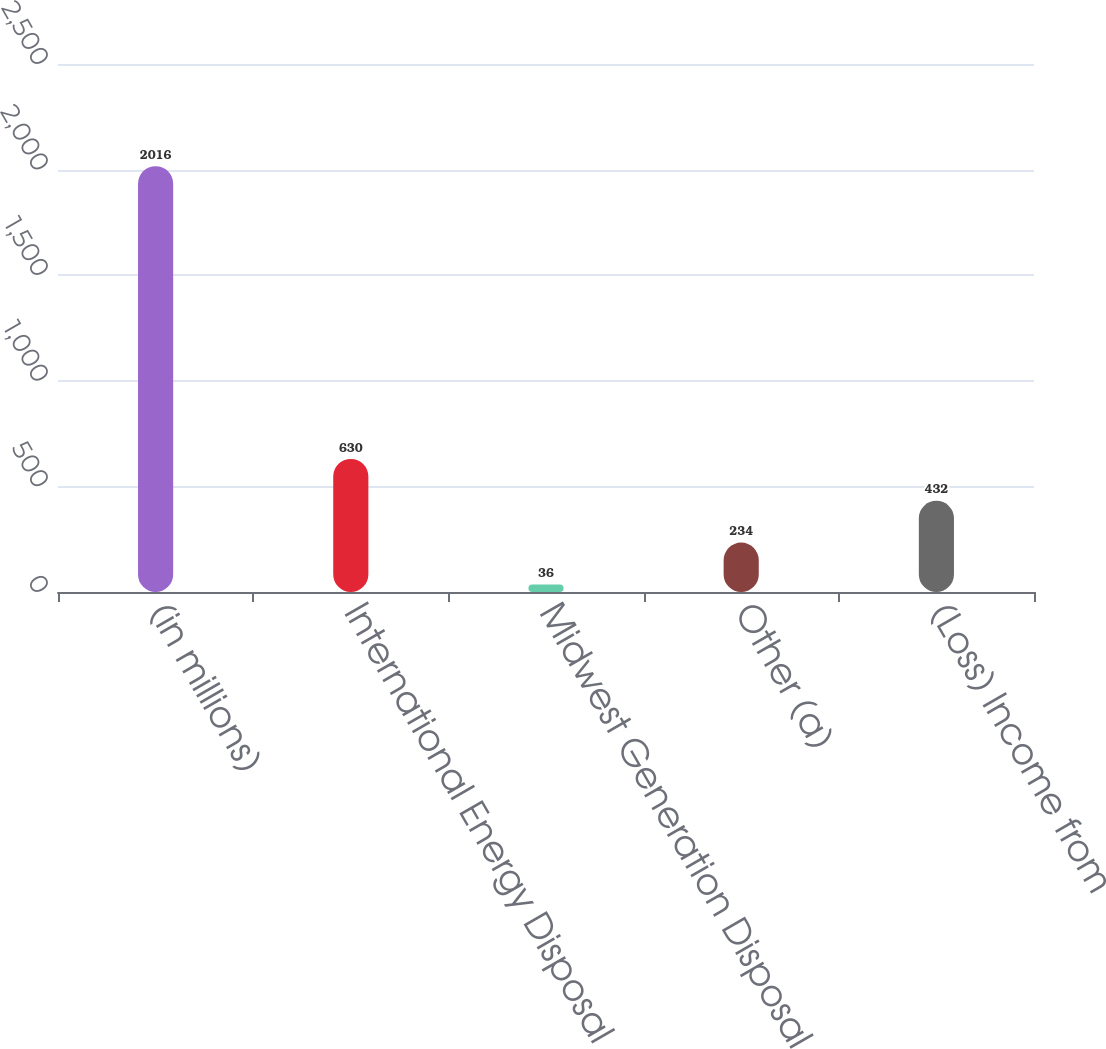<chart> <loc_0><loc_0><loc_500><loc_500><bar_chart><fcel>(in millions)<fcel>International Energy Disposal<fcel>Midwest Generation Disposal<fcel>Other (a)<fcel>(Loss) Income from<nl><fcel>2016<fcel>630<fcel>36<fcel>234<fcel>432<nl></chart> 